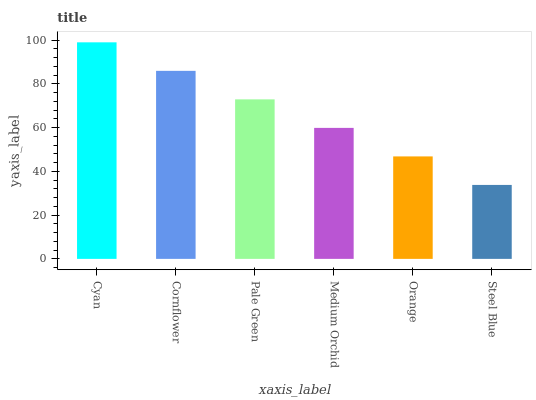Is Steel Blue the minimum?
Answer yes or no. Yes. Is Cyan the maximum?
Answer yes or no. Yes. Is Cornflower the minimum?
Answer yes or no. No. Is Cornflower the maximum?
Answer yes or no. No. Is Cyan greater than Cornflower?
Answer yes or no. Yes. Is Cornflower less than Cyan?
Answer yes or no. Yes. Is Cornflower greater than Cyan?
Answer yes or no. No. Is Cyan less than Cornflower?
Answer yes or no. No. Is Pale Green the high median?
Answer yes or no. Yes. Is Medium Orchid the low median?
Answer yes or no. Yes. Is Steel Blue the high median?
Answer yes or no. No. Is Steel Blue the low median?
Answer yes or no. No. 